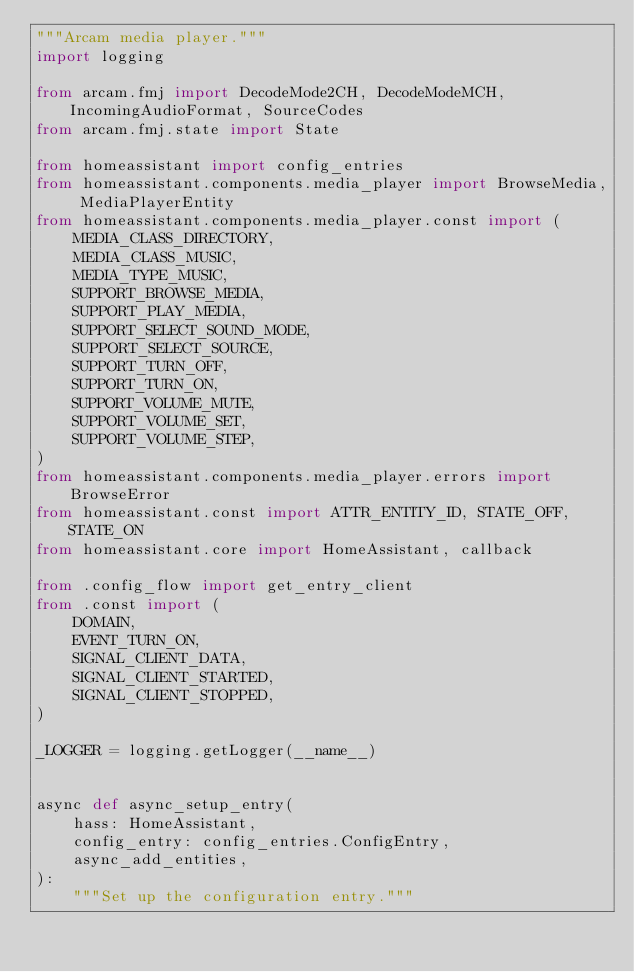Convert code to text. <code><loc_0><loc_0><loc_500><loc_500><_Python_>"""Arcam media player."""
import logging

from arcam.fmj import DecodeMode2CH, DecodeModeMCH, IncomingAudioFormat, SourceCodes
from arcam.fmj.state import State

from homeassistant import config_entries
from homeassistant.components.media_player import BrowseMedia, MediaPlayerEntity
from homeassistant.components.media_player.const import (
    MEDIA_CLASS_DIRECTORY,
    MEDIA_CLASS_MUSIC,
    MEDIA_TYPE_MUSIC,
    SUPPORT_BROWSE_MEDIA,
    SUPPORT_PLAY_MEDIA,
    SUPPORT_SELECT_SOUND_MODE,
    SUPPORT_SELECT_SOURCE,
    SUPPORT_TURN_OFF,
    SUPPORT_TURN_ON,
    SUPPORT_VOLUME_MUTE,
    SUPPORT_VOLUME_SET,
    SUPPORT_VOLUME_STEP,
)
from homeassistant.components.media_player.errors import BrowseError
from homeassistant.const import ATTR_ENTITY_ID, STATE_OFF, STATE_ON
from homeassistant.core import HomeAssistant, callback

from .config_flow import get_entry_client
from .const import (
    DOMAIN,
    EVENT_TURN_ON,
    SIGNAL_CLIENT_DATA,
    SIGNAL_CLIENT_STARTED,
    SIGNAL_CLIENT_STOPPED,
)

_LOGGER = logging.getLogger(__name__)


async def async_setup_entry(
    hass: HomeAssistant,
    config_entry: config_entries.ConfigEntry,
    async_add_entities,
):
    """Set up the configuration entry."""
</code> 